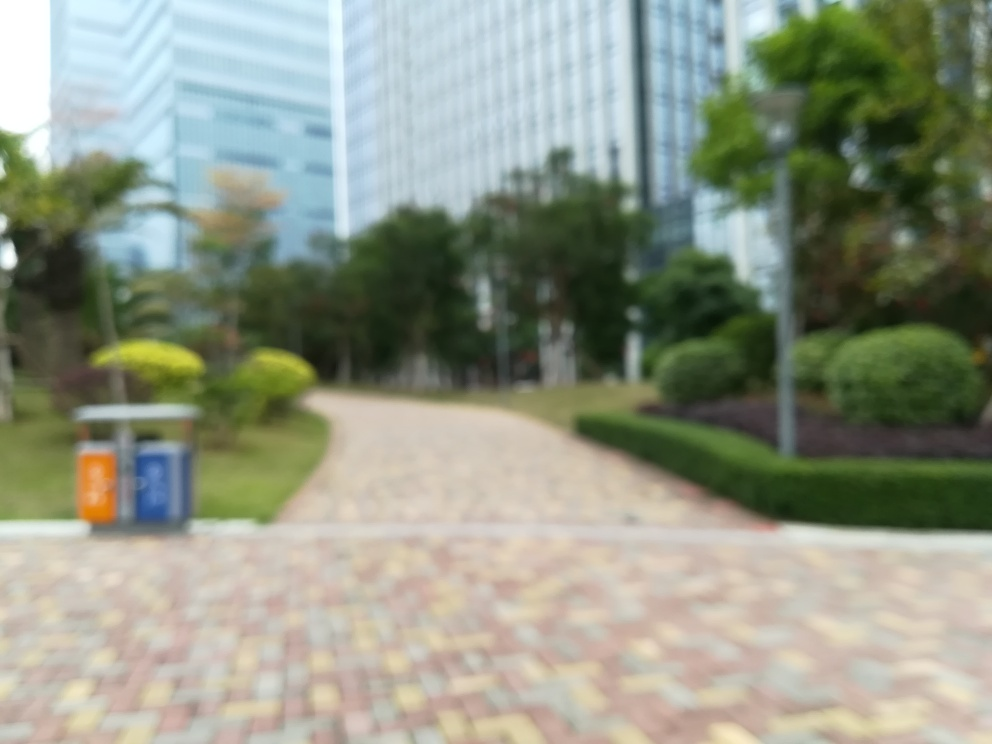What elements of this image could be improved to enhance its quality? Improving the focus to achieve a sharp image would be the most significant enhancement. Additionally, increasing the resolution and adjusting the composition to adhere to the rule of thirds could also contribute to a more engaging and aesthetically pleasing image. 